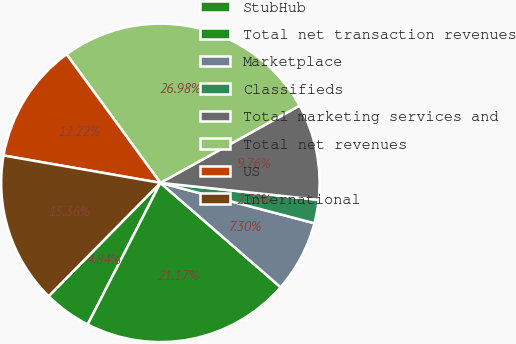<chart> <loc_0><loc_0><loc_500><loc_500><pie_chart><fcel>StubHub<fcel>Total net transaction revenues<fcel>Marketplace<fcel>Classifieds<fcel>Total marketing services and<fcel>Total net revenues<fcel>US<fcel>International<nl><fcel>4.84%<fcel>21.17%<fcel>7.3%<fcel>2.38%<fcel>9.76%<fcel>26.98%<fcel>12.22%<fcel>15.36%<nl></chart> 